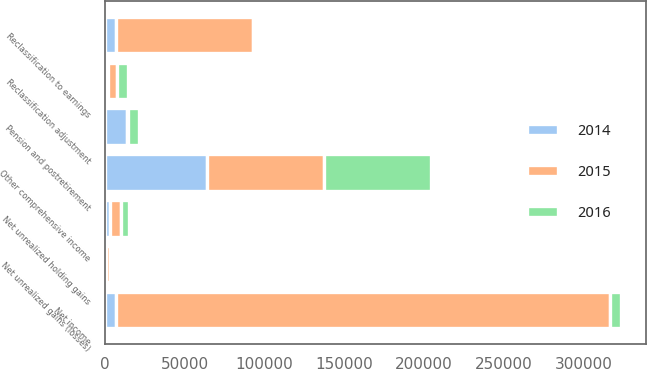Convert chart to OTSL. <chart><loc_0><loc_0><loc_500><loc_500><stacked_bar_chart><ecel><fcel>Net income<fcel>Net unrealized holding gains<fcel>Reclassification to earnings<fcel>Net unrealized gains (losses)<fcel>Reclassification adjustment<fcel>Pension and postretirement<fcel>Other comprehensive income<nl><fcel>2016<fcel>6993<fcel>4993<fcel>63<fcel>2100<fcel>7000<fcel>6986<fcel>66969<nl><fcel>2015<fcel>309471<fcel>7455<fcel>86023<fcel>2552<fcel>5583<fcel>557<fcel>73429<nl><fcel>2014<fcel>6993<fcel>2664<fcel>6447<fcel>390<fcel>1605<fcel>13494<fcel>64060<nl></chart> 